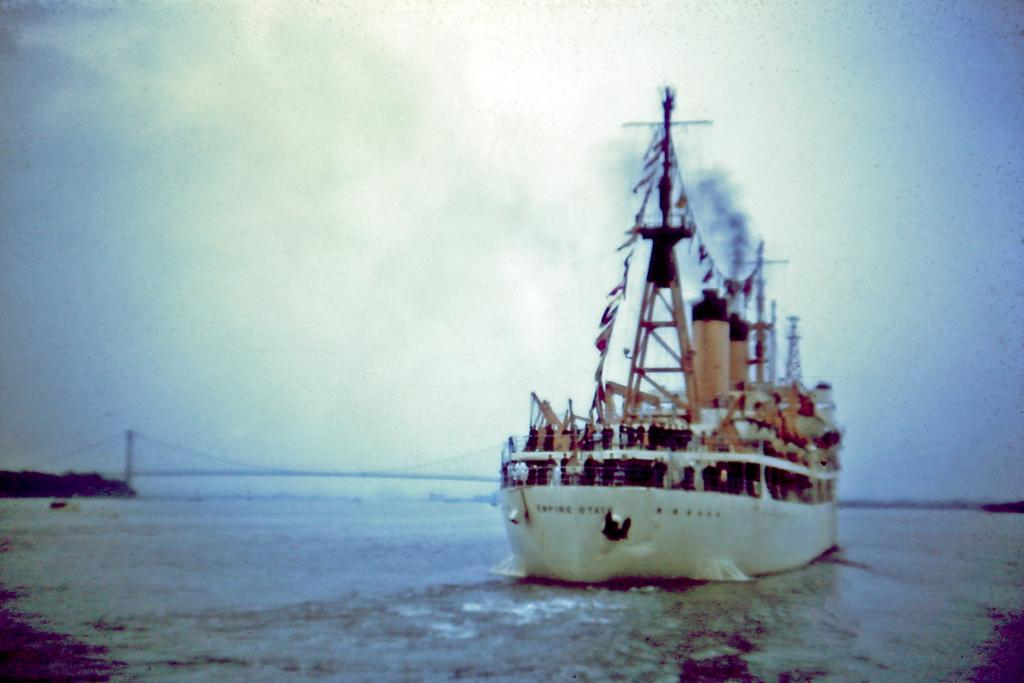What is the main subject of the image? The main subject of the image is a ship. Where is the ship located? The ship is on the water. How many rings are visible on the ship's deck in the image? There are no rings visible on the ship's deck in the image. What type of root can be seen growing near the ship in the image? There is no root present in the image; it features a ship on the water. 